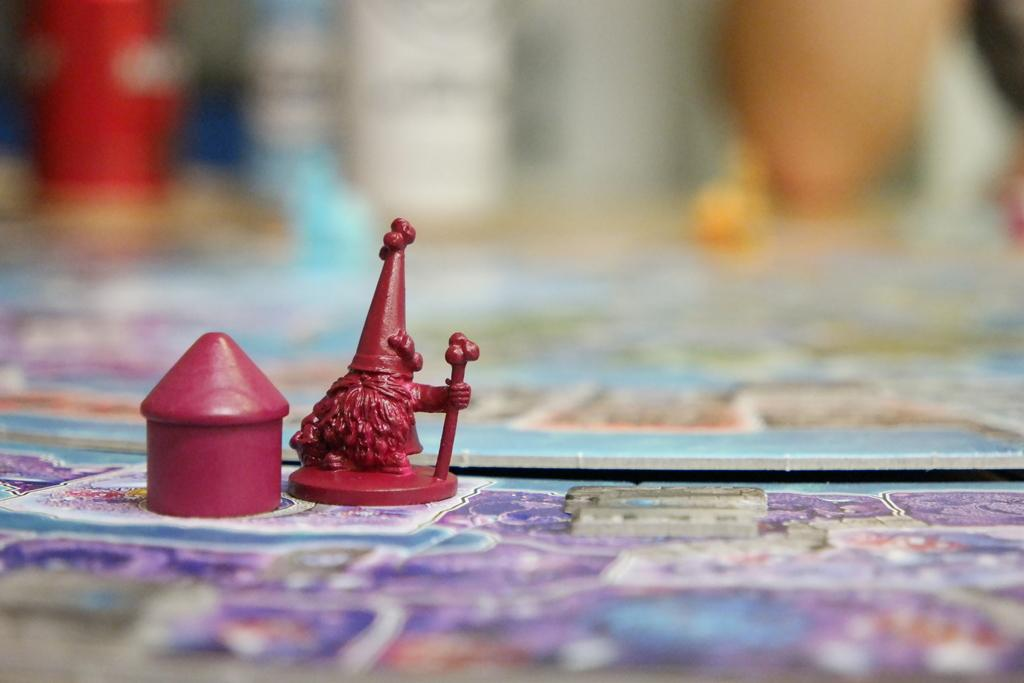What can be seen in the image? There are objects in the image. What is located at the bottom of the image? There is a board at the bottom of the image. How would you describe the background of the image? The background of the image is blurry. Can you see a beetle crawling on the board in the image? There is no beetle present in the image. What is the tongue doing in the image? There is no tongue present in the image. 